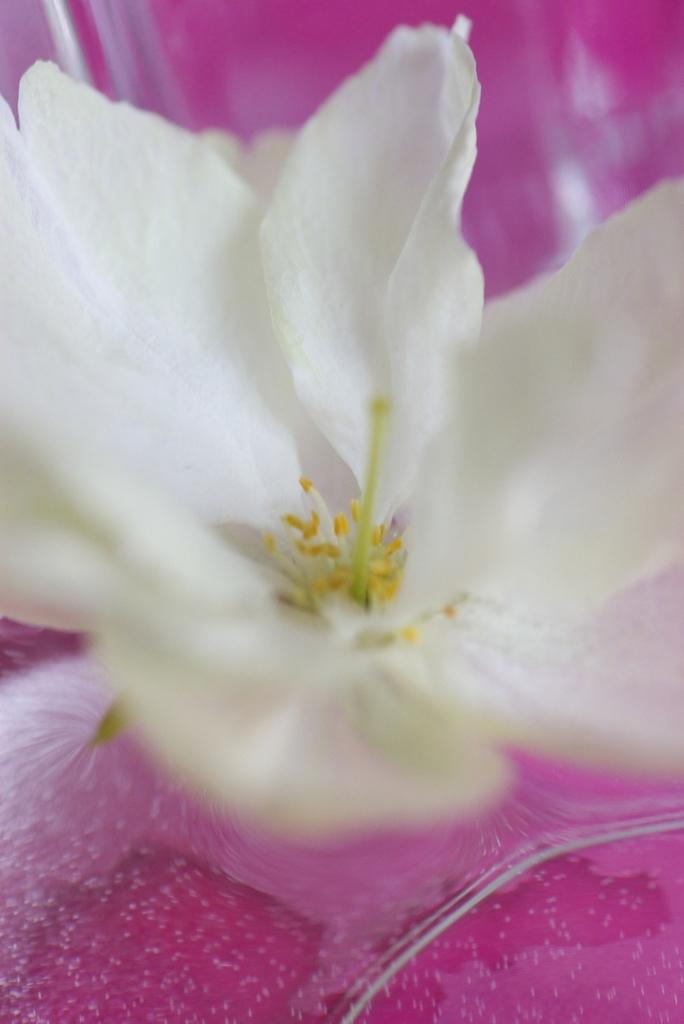What is the main subject of the image? There is a flower in the image. Can you describe the colors of the flower? The flower has white, yellow, and green colors. What can be seen in the background of the image? There is a pink colored object in the background of the image. What type of wine is being served in the image? There is no wine present in the image; it features a flower with white, yellow, and green colors, and a pink colored object in the background. How much force is being applied to the celery in the image? There is no celery present in the image, and therefore no force can be applied to it. 